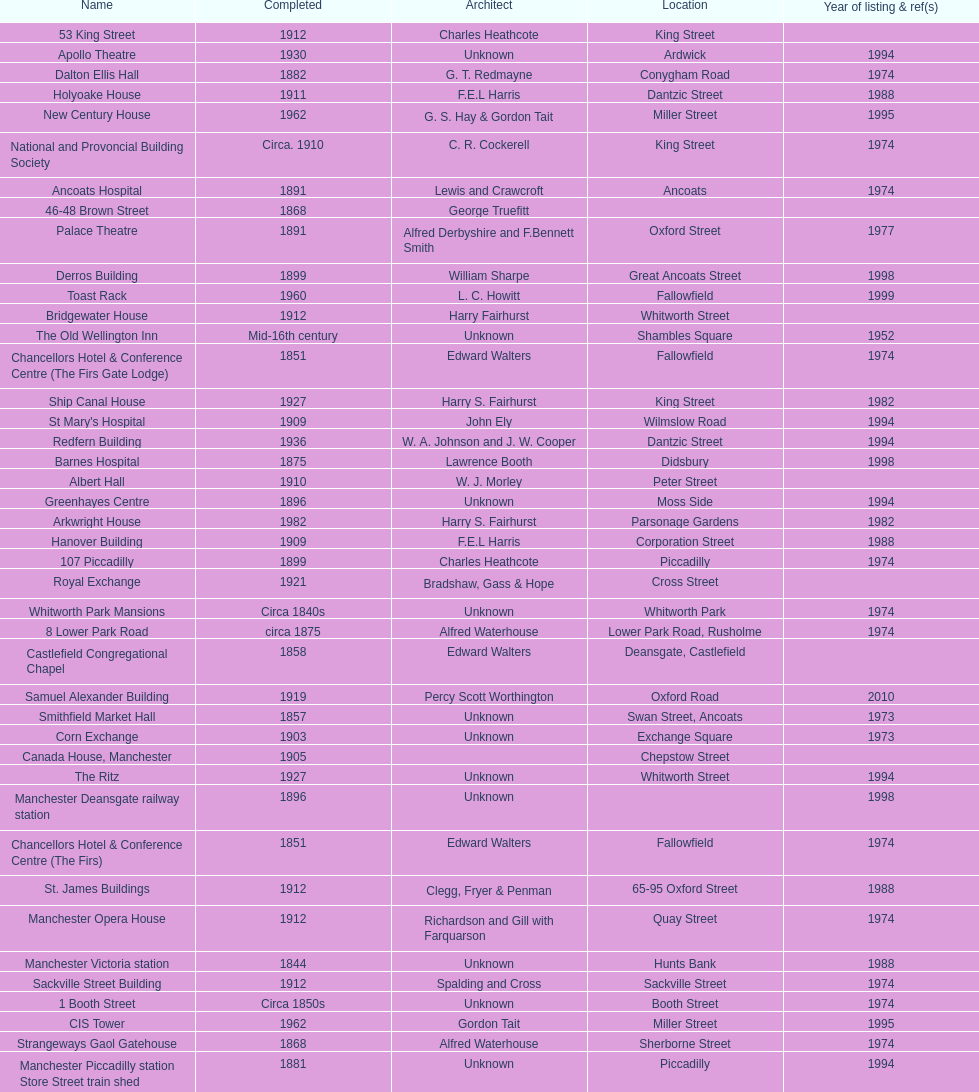Which year has the most buildings listed? 1974. Can you give me this table as a dict? {'header': ['Name', 'Completed', 'Architect', 'Location', 'Year of listing & ref(s)'], 'rows': [['53 King Street', '1912', 'Charles Heathcote', 'King Street', ''], ['Apollo Theatre', '1930', 'Unknown', 'Ardwick', '1994'], ['Dalton Ellis Hall', '1882', 'G. T. Redmayne', 'Conygham Road', '1974'], ['Holyoake House', '1911', 'F.E.L Harris', 'Dantzic Street', '1988'], ['New Century House', '1962', 'G. S. Hay & Gordon Tait', 'Miller Street', '1995'], ['National and Provoncial Building Society', 'Circa. 1910', 'C. R. Cockerell', 'King Street', '1974'], ['Ancoats Hospital', '1891', 'Lewis and Crawcroft', 'Ancoats', '1974'], ['46-48 Brown Street', '1868', 'George Truefitt', '', ''], ['Palace Theatre', '1891', 'Alfred Derbyshire and F.Bennett Smith', 'Oxford Street', '1977'], ['Derros Building', '1899', 'William Sharpe', 'Great Ancoats Street', '1998'], ['Toast Rack', '1960', 'L. C. Howitt', 'Fallowfield', '1999'], ['Bridgewater House', '1912', 'Harry Fairhurst', 'Whitworth Street', ''], ['The Old Wellington Inn', 'Mid-16th century', 'Unknown', 'Shambles Square', '1952'], ['Chancellors Hotel & Conference Centre (The Firs Gate Lodge)', '1851', 'Edward Walters', 'Fallowfield', '1974'], ['Ship Canal House', '1927', 'Harry S. Fairhurst', 'King Street', '1982'], ["St Mary's Hospital", '1909', 'John Ely', 'Wilmslow Road', '1994'], ['Redfern Building', '1936', 'W. A. Johnson and J. W. Cooper', 'Dantzic Street', '1994'], ['Barnes Hospital', '1875', 'Lawrence Booth', 'Didsbury', '1998'], ['Albert Hall', '1910', 'W. J. Morley', 'Peter Street', ''], ['Greenhayes Centre', '1896', 'Unknown', 'Moss Side', '1994'], ['Arkwright House', '1982', 'Harry S. Fairhurst', 'Parsonage Gardens', '1982'], ['Hanover Building', '1909', 'F.E.L Harris', 'Corporation Street', '1988'], ['107 Piccadilly', '1899', 'Charles Heathcote', 'Piccadilly', '1974'], ['Royal Exchange', '1921', 'Bradshaw, Gass & Hope', 'Cross Street', ''], ['Whitworth Park Mansions', 'Circa 1840s', 'Unknown', 'Whitworth Park', '1974'], ['8 Lower Park Road', 'circa 1875', 'Alfred Waterhouse', 'Lower Park Road, Rusholme', '1974'], ['Castlefield Congregational Chapel', '1858', 'Edward Walters', 'Deansgate, Castlefield', ''], ['Samuel Alexander Building', '1919', 'Percy Scott Worthington', 'Oxford Road', '2010'], ['Smithfield Market Hall', '1857', 'Unknown', 'Swan Street, Ancoats', '1973'], ['Corn Exchange', '1903', 'Unknown', 'Exchange Square', '1973'], ['Canada House, Manchester', '1905', '', 'Chepstow Street', ''], ['The Ritz', '1927', 'Unknown', 'Whitworth Street', '1994'], ['Manchester Deansgate railway station', '1896', 'Unknown', '', '1998'], ['Chancellors Hotel & Conference Centre (The Firs)', '1851', 'Edward Walters', 'Fallowfield', '1974'], ['St. James Buildings', '1912', 'Clegg, Fryer & Penman', '65-95 Oxford Street', '1988'], ['Manchester Opera House', '1912', 'Richardson and Gill with Farquarson', 'Quay Street', '1974'], ['Manchester Victoria station', '1844', 'Unknown', 'Hunts Bank', '1988'], ['Sackville Street Building', '1912', 'Spalding and Cross', 'Sackville Street', '1974'], ['1 Booth Street', 'Circa 1850s', 'Unknown', 'Booth Street', '1974'], ['CIS Tower', '1962', 'Gordon Tait', 'Miller Street', '1995'], ['Strangeways Gaol Gatehouse', '1868', 'Alfred Waterhouse', 'Sherborne Street', '1974'], ['Manchester Piccadilly station Store Street train shed', '1881', 'Unknown', 'Piccadilly', '1994'], ['Cooperative Press', 'Late 19th century', 'Unknown', 'Naples Street, Ancoats', '1994'], ['29 Swan Street', 'circa 1865s', 'Unknown', 'Swan Street, Ancoats', '1989'], ['Barlow Hall', '15th century (altered since)', 'Unknown', 'Chorlton-cum-Hardy', '1974 (downgraded in 1994)'], ['Strangeways Prison ventilation and watch tower', '1868', 'Alfred Waterhouse', 'Sherborne Street', '1974'], ['Manchester Oxford Road railway station', '1960', 'W. R. Headley and Max Glendinning', 'Oxford Road', '1995'], ['235-291 Deansgate', '1899', 'Unknown', 'Deansgate', '1988'], ['Theatre Royal', '1845', 'Irwin and Chester', 'Peter Street', '1974'], ['50 Newton Street', 'Circa 1900', 'Clegg & Knowles', 'Newton Street, Piccadilly', '1988']]} 